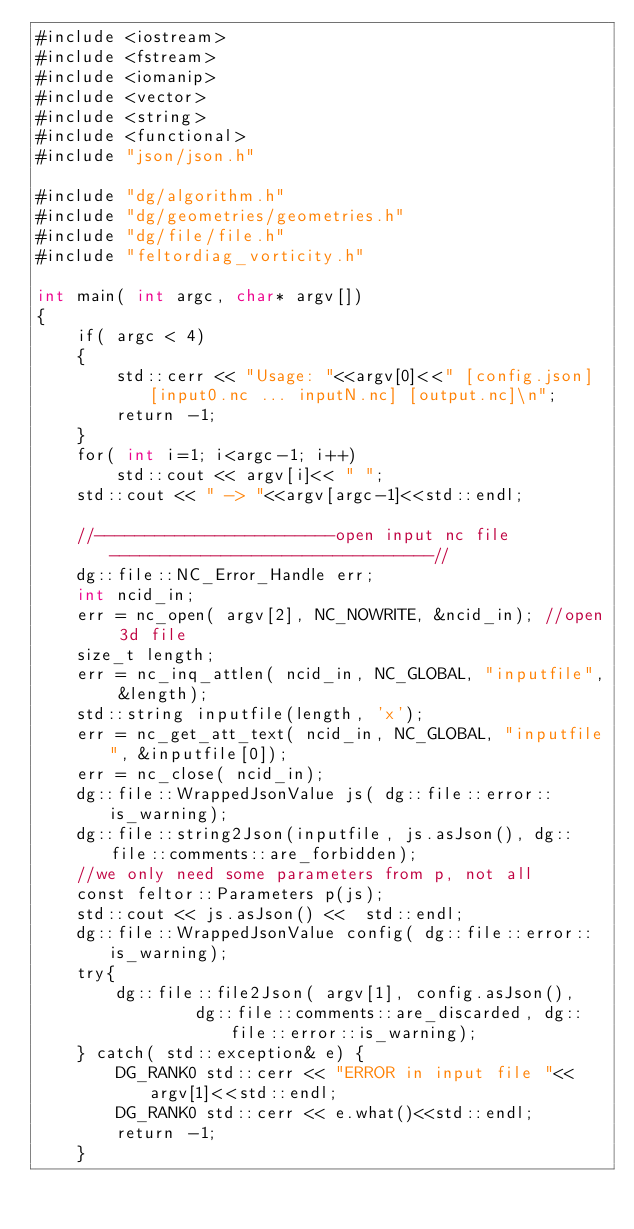Convert code to text. <code><loc_0><loc_0><loc_500><loc_500><_Cuda_>#include <iostream>
#include <fstream>
#include <iomanip>
#include <vector>
#include <string>
#include <functional>
#include "json/json.h"

#include "dg/algorithm.h"
#include "dg/geometries/geometries.h"
#include "dg/file/file.h"
#include "feltordiag_vorticity.h"

int main( int argc, char* argv[])
{
    if( argc < 4)
    {
        std::cerr << "Usage: "<<argv[0]<<" [config.json] [input0.nc ... inputN.nc] [output.nc]\n";
        return -1;
    }
    for( int i=1; i<argc-1; i++)
        std::cout << argv[i]<< " ";
    std::cout << " -> "<<argv[argc-1]<<std::endl;

    //------------------------open input nc file--------------------------------//
    dg::file::NC_Error_Handle err;
    int ncid_in;
    err = nc_open( argv[2], NC_NOWRITE, &ncid_in); //open 3d file
    size_t length;
    err = nc_inq_attlen( ncid_in, NC_GLOBAL, "inputfile", &length);
    std::string inputfile(length, 'x');
    err = nc_get_att_text( ncid_in, NC_GLOBAL, "inputfile", &inputfile[0]);
    err = nc_close( ncid_in);
    dg::file::WrappedJsonValue js( dg::file::error::is_warning);
    dg::file::string2Json(inputfile, js.asJson(), dg::file::comments::are_forbidden);
    //we only need some parameters from p, not all
    const feltor::Parameters p(js);
    std::cout << js.asJson() <<  std::endl;
    dg::file::WrappedJsonValue config( dg::file::error::is_warning);
    try{
        dg::file::file2Json( argv[1], config.asJson(),
                dg::file::comments::are_discarded, dg::file::error::is_warning);
    } catch( std::exception& e) {
        DG_RANK0 std::cerr << "ERROR in input file "<<argv[1]<<std::endl;
        DG_RANK0 std::cerr << e.what()<<std::endl;
        return -1;
    }
</code> 